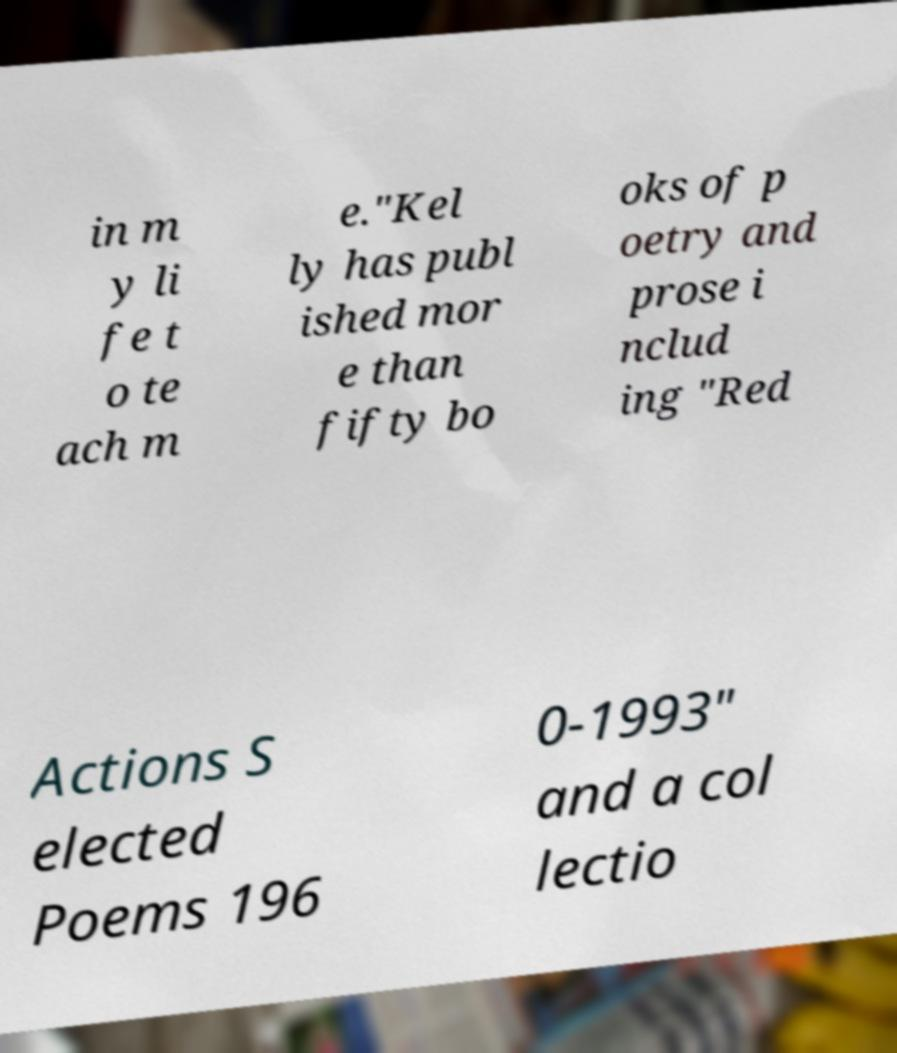Please read and relay the text visible in this image. What does it say? in m y li fe t o te ach m e.″Kel ly has publ ished mor e than fifty bo oks of p oetry and prose i nclud ing "Red Actions S elected Poems 196 0-1993" and a col lectio 